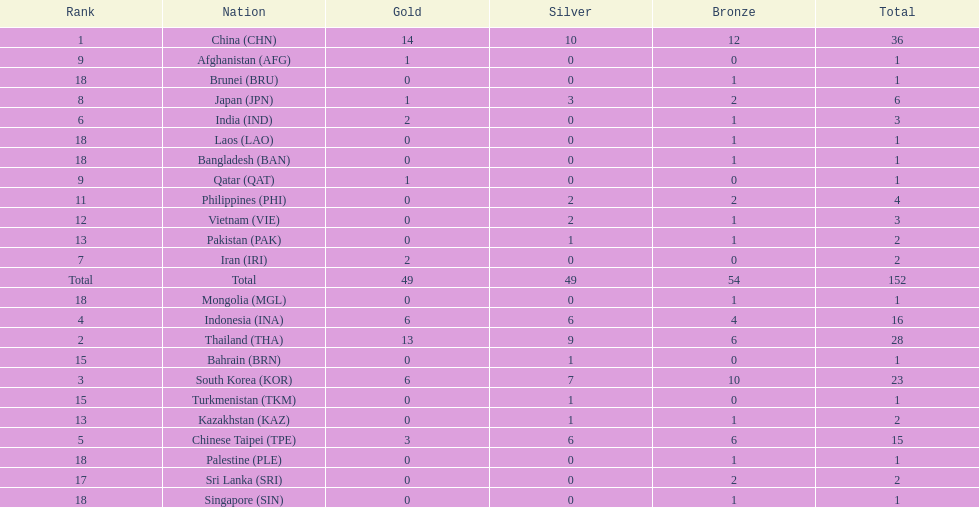Which nation finished first in total medals earned? China (CHN). 